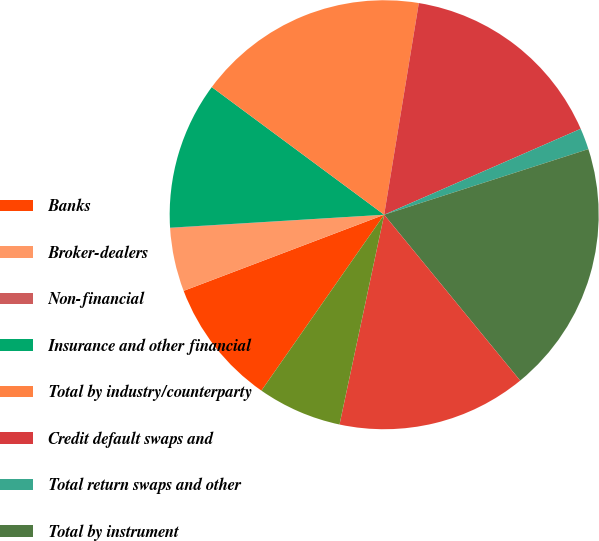<chart> <loc_0><loc_0><loc_500><loc_500><pie_chart><fcel>Banks<fcel>Broker-dealers<fcel>Non-financial<fcel>Insurance and other financial<fcel>Total by industry/counterparty<fcel>Credit default swaps and<fcel>Total return swaps and other<fcel>Total by instrument<fcel>Investment grade<fcel>Non-investment grade<nl><fcel>9.53%<fcel>4.78%<fcel>0.03%<fcel>11.11%<fcel>17.44%<fcel>15.86%<fcel>1.61%<fcel>19.02%<fcel>14.27%<fcel>6.36%<nl></chart> 